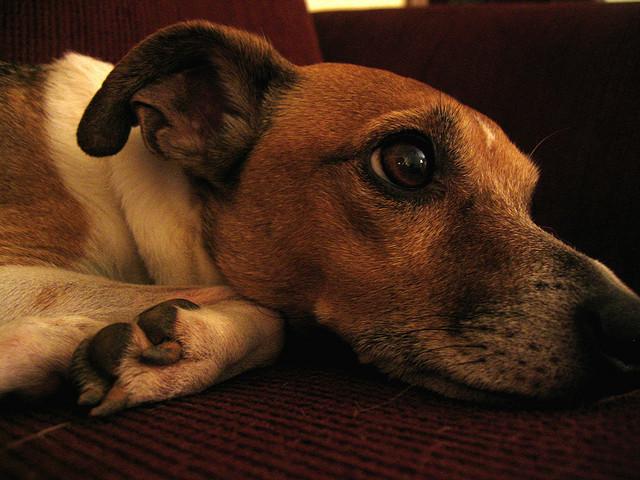What kind of dog is this?
Be succinct. Beagle. What is the dog sitting on?
Keep it brief. Couch. What kind of animal is this?
Short answer required. Dog. Should a pet have a seat belt?
Short answer required. No. Is this dog alone in this photo?
Short answer required. Yes. What color eyes does this animal have?
Give a very brief answer. Brown. What color is the dogs inner ear?
Concise answer only. Brown. Is the dog on furniture?
Concise answer only. Yes. Is this dog asleep?
Quick response, please. No. Is the dog comfortable?
Answer briefly. Yes. Is the dog wearing a collar?
Write a very short answer. No. Is the dog being naughty?
Answer briefly. No. Does this dog like to play?
Quick response, please. Yes. Does the dog have big ears?
Quick response, please. Yes. What type of animal is this?
Answer briefly. Dog. What color are this dog's eyes?
Give a very brief answer. Brown. What is the dog looking at?
Answer briefly. Unknown. What type of dog?
Be succinct. Beagle. What color is the dog?
Be succinct. Brown and white. What color is the dog's fur?
Answer briefly. Brown. Does the dog have a collar?
Write a very short answer. No. 